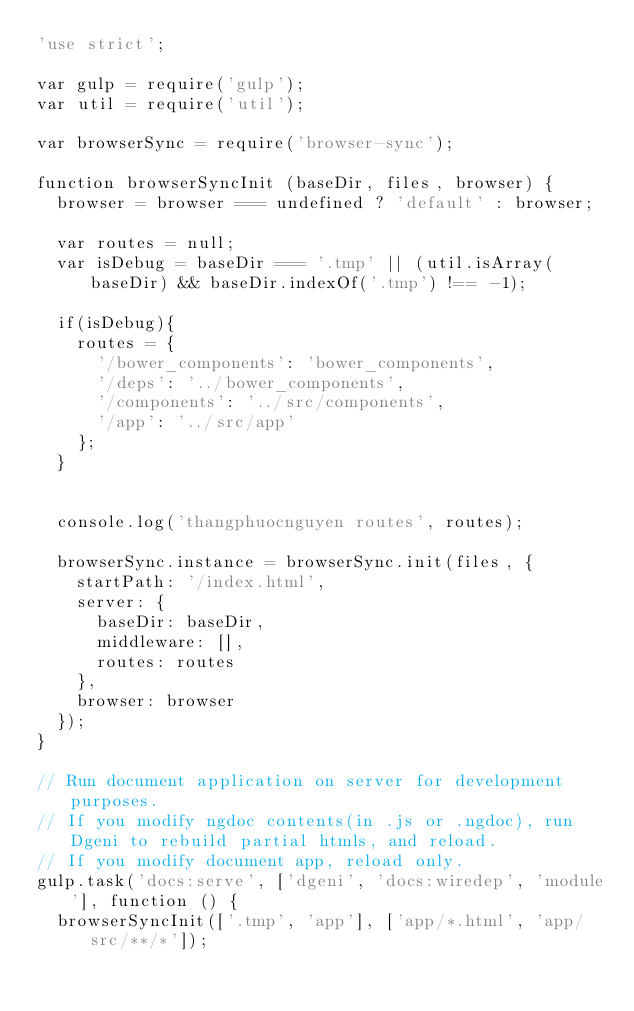<code> <loc_0><loc_0><loc_500><loc_500><_JavaScript_>'use strict';

var gulp = require('gulp');
var util = require('util');

var browserSync = require('browser-sync');

function browserSyncInit (baseDir, files, browser) {
  browser = browser === undefined ? 'default' : browser;

  var routes = null;
  var isDebug = baseDir === '.tmp' || (util.isArray(baseDir) && baseDir.indexOf('.tmp') !== -1);
  
	if(isDebug){
		routes = {
			'/bower_components': 'bower_components',
			'/deps': '../bower_components',
      '/components': '../src/components',
      '/app': '../src/app'
    };
	}


  console.log('thangphuocnguyen routes', routes);

	browserSync.instance = browserSync.init(files, {
		startPath: '/index.html',
		server: {
			baseDir: baseDir,
			middleware: [],
			routes: routes
		},
		browser: browser
	});
}

// Run document application on server for development purposes.
// If you modify ngdoc contents(in .js or .ngdoc), run Dgeni to rebuild partial htmls, and reload.
// If you modify document app, reload only.
gulp.task('docs:serve', ['dgeni', 'docs:wiredep', 'module'], function () {
	browserSyncInit(['.tmp', 'app'], ['app/*.html', 'app/src/**/*']);</code> 